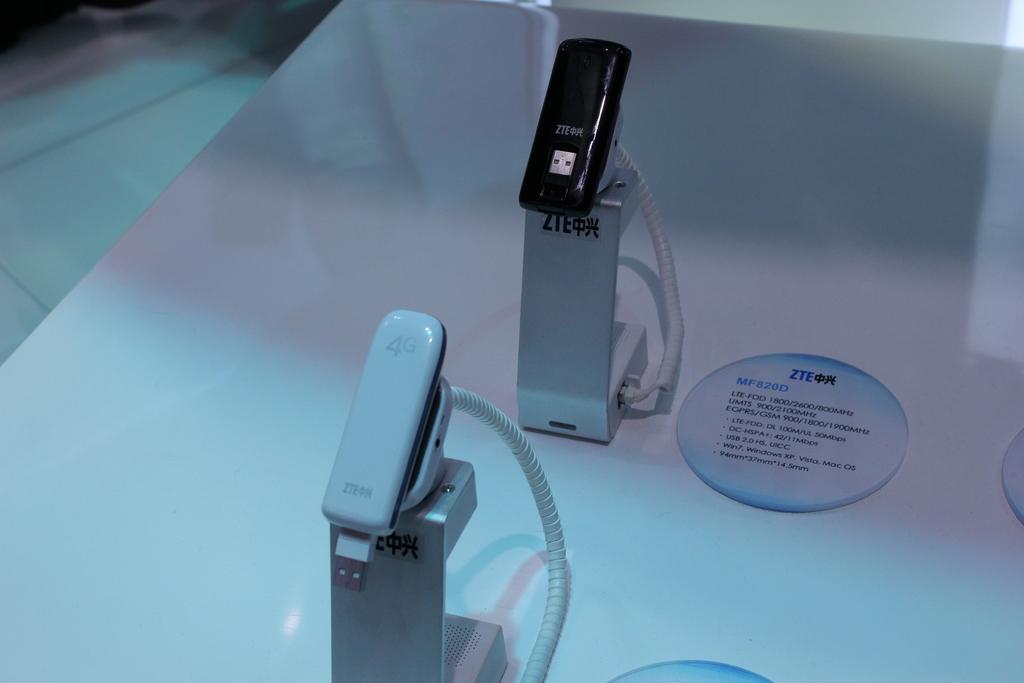What brand is this player?  3 letters?
Ensure brevity in your answer.  Zte. The three letter is zte?
Offer a very short reply. Yes. 